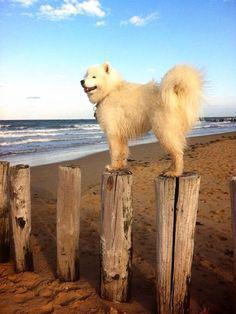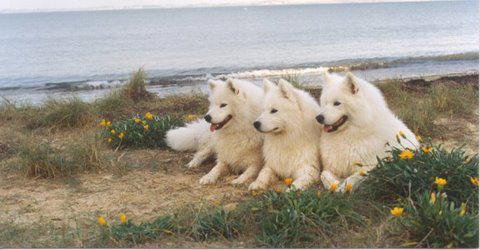The first image is the image on the left, the second image is the image on the right. Evaluate the accuracy of this statement regarding the images: "A white dog is standing on the rocky shore of a beach.". Is it true? Answer yes or no. No. The first image is the image on the left, the second image is the image on the right. Examine the images to the left and right. Is the description "The right image includes at least twice the number of dogs as the left image." accurate? Answer yes or no. Yes. 